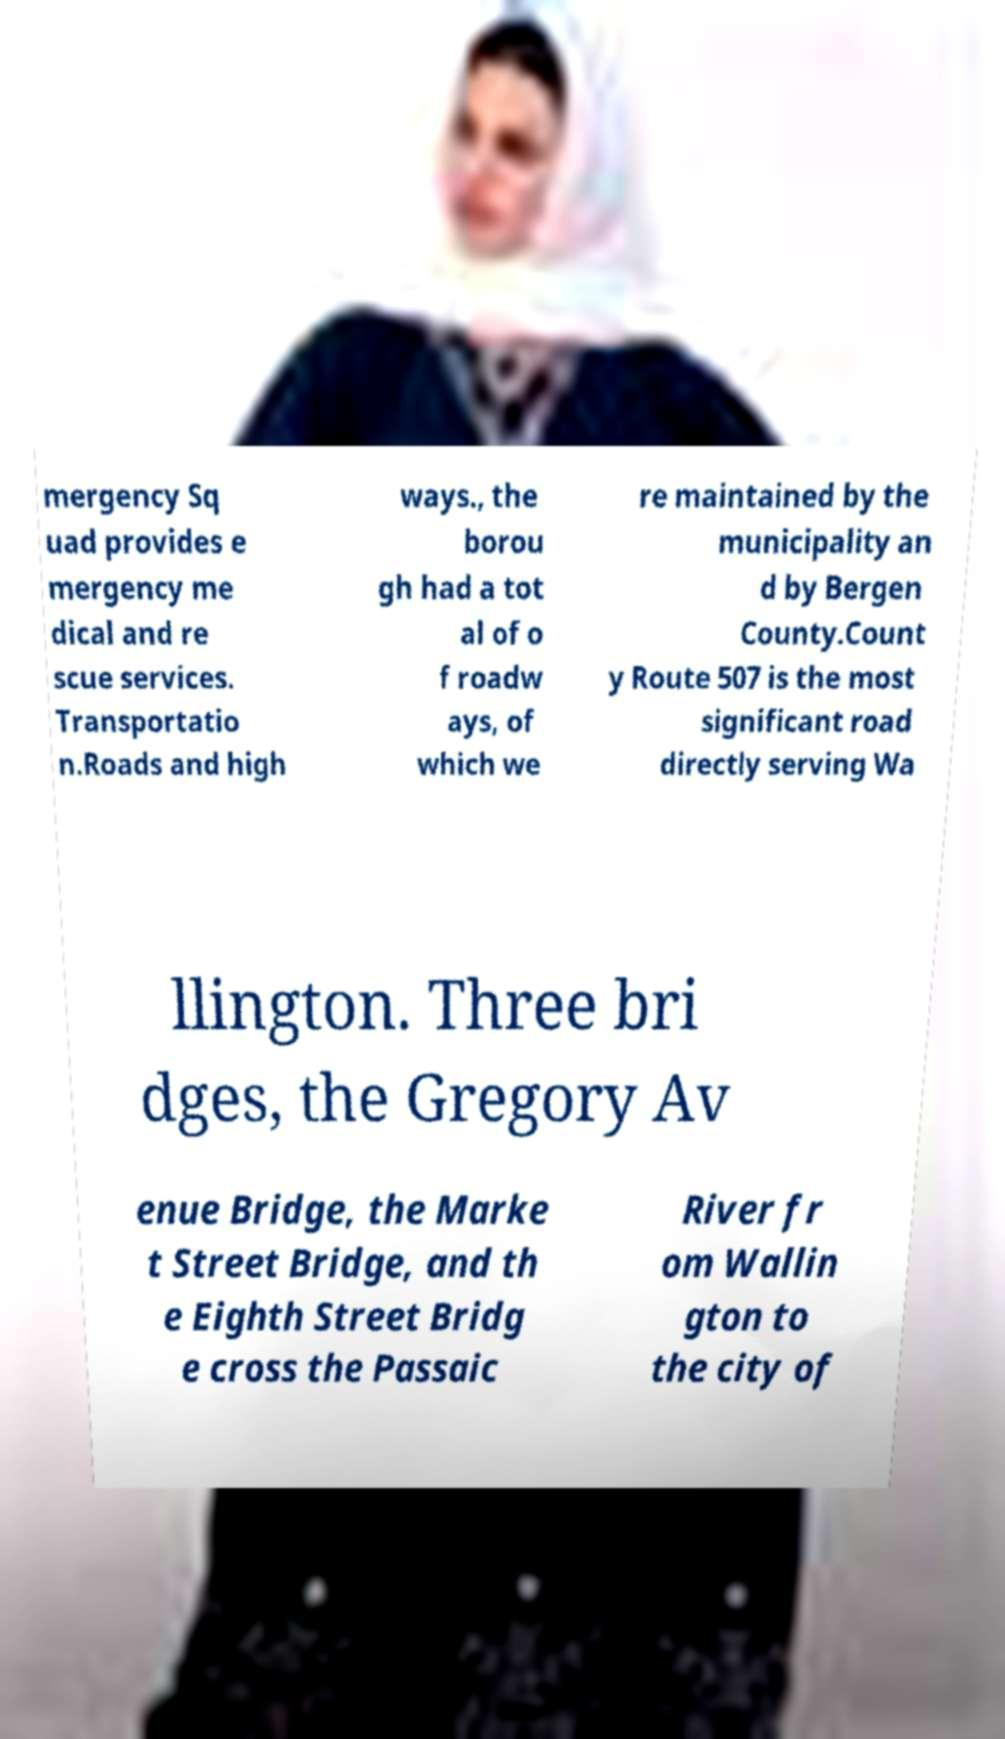For documentation purposes, I need the text within this image transcribed. Could you provide that? mergency Sq uad provides e mergency me dical and re scue services. Transportatio n.Roads and high ways., the borou gh had a tot al of o f roadw ays, of which we re maintained by the municipality an d by Bergen County.Count y Route 507 is the most significant road directly serving Wa llington. Three bri dges, the Gregory Av enue Bridge, the Marke t Street Bridge, and th e Eighth Street Bridg e cross the Passaic River fr om Wallin gton to the city of 